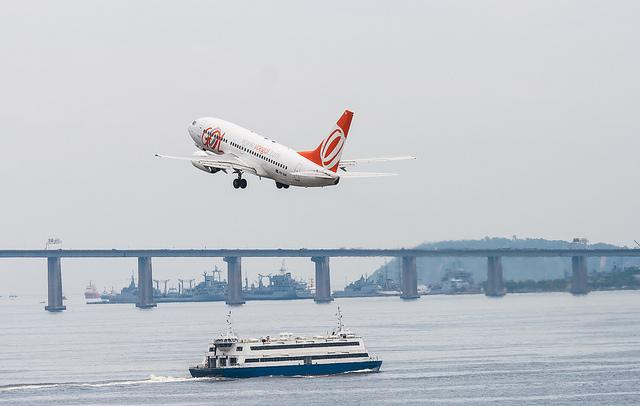What is the plane hovering over? Please explain your reasoning. boat. The plane is clearly visible in the image and by looking directly under it, answer a is seen. 